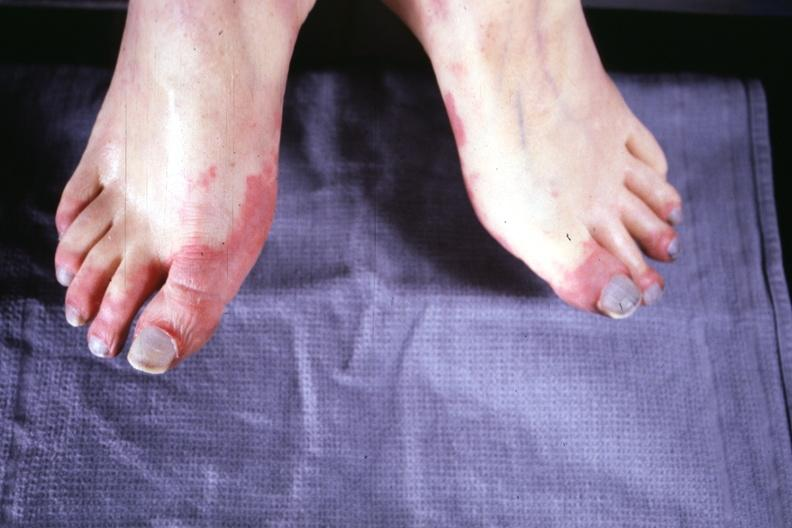s gangrene present?
Answer the question using a single word or phrase. Yes 